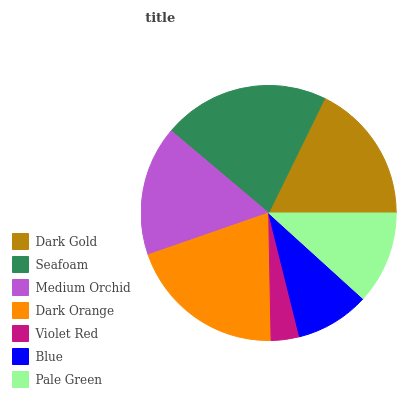Is Violet Red the minimum?
Answer yes or no. Yes. Is Seafoam the maximum?
Answer yes or no. Yes. Is Medium Orchid the minimum?
Answer yes or no. No. Is Medium Orchid the maximum?
Answer yes or no. No. Is Seafoam greater than Medium Orchid?
Answer yes or no. Yes. Is Medium Orchid less than Seafoam?
Answer yes or no. Yes. Is Medium Orchid greater than Seafoam?
Answer yes or no. No. Is Seafoam less than Medium Orchid?
Answer yes or no. No. Is Medium Orchid the high median?
Answer yes or no. Yes. Is Medium Orchid the low median?
Answer yes or no. Yes. Is Violet Red the high median?
Answer yes or no. No. Is Seafoam the low median?
Answer yes or no. No. 